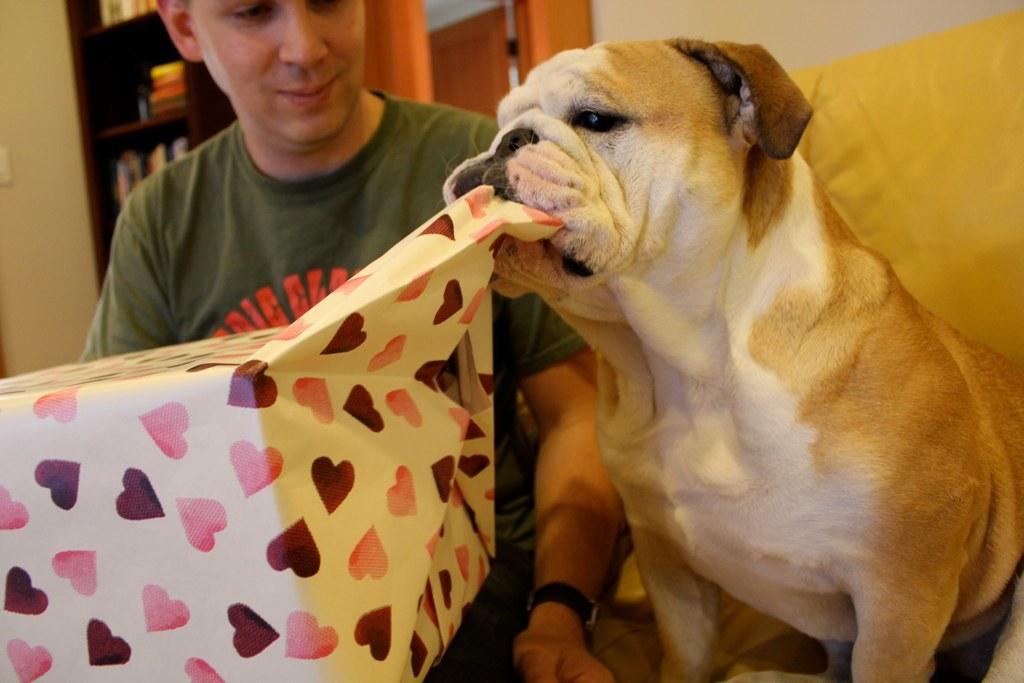What type of animal is in the image? There is a dog in the image. Who or what else is in the image? There is a person in the image. What object might be related to a celebration or special occasion? There is a gift box in the image. What type of items can be seen related to learning or reading? There are books in the image. What type of brass instrument is the dog playing in the image? There is no brass instrument present in the image. What type of lock is securing the gift box in the image? There is no lock visible on the gift box in the image. 